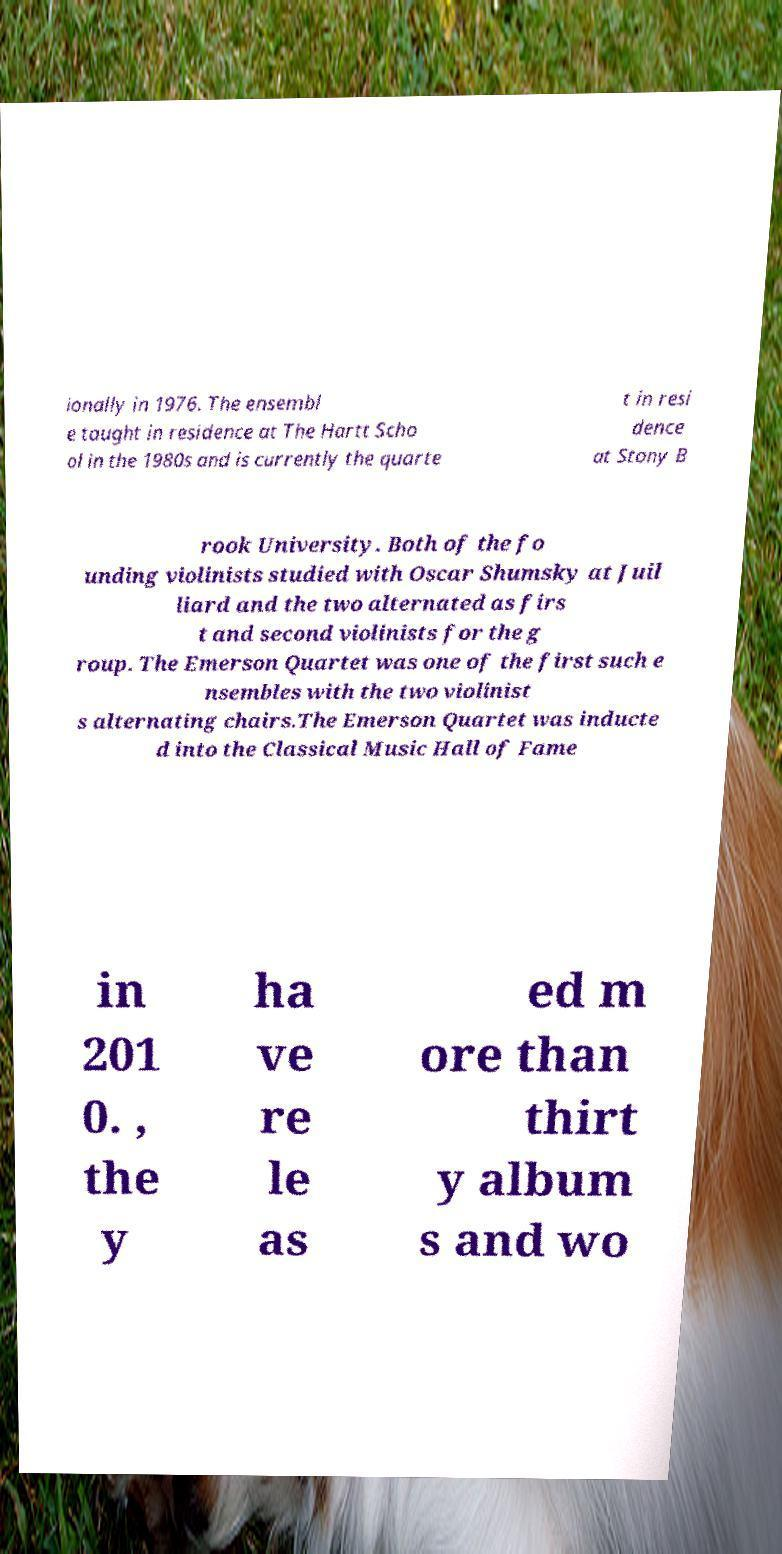Please read and relay the text visible in this image. What does it say? ionally in 1976. The ensembl e taught in residence at The Hartt Scho ol in the 1980s and is currently the quarte t in resi dence at Stony B rook University. Both of the fo unding violinists studied with Oscar Shumsky at Juil liard and the two alternated as firs t and second violinists for the g roup. The Emerson Quartet was one of the first such e nsembles with the two violinist s alternating chairs.The Emerson Quartet was inducte d into the Classical Music Hall of Fame in 201 0. , the y ha ve re le as ed m ore than thirt y album s and wo 